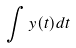<formula> <loc_0><loc_0><loc_500><loc_500>\int y ( t ) d t</formula> 